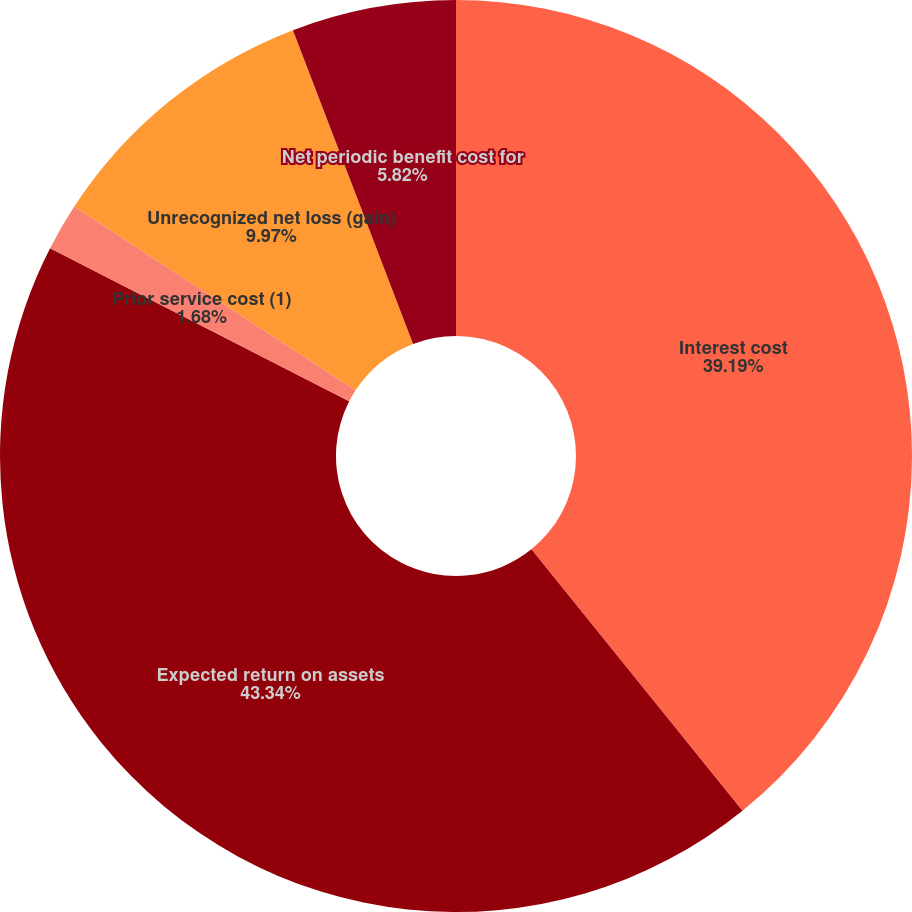<chart> <loc_0><loc_0><loc_500><loc_500><pie_chart><fcel>Interest cost<fcel>Expected return on assets<fcel>Prior service cost (1)<fcel>Unrecognized net loss (gain)<fcel>Net periodic benefit cost for<nl><fcel>39.19%<fcel>43.34%<fcel>1.68%<fcel>9.97%<fcel>5.82%<nl></chart> 